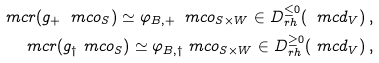<formula> <loc_0><loc_0><loc_500><loc_500>\ m c r ( g _ { + } \ m c o _ { S } ) \simeq \varphi _ { B , + } \ m c o _ { S \times W } \in D ^ { \leq 0 } _ { r h } ( \ m c d _ { V } ) \, , \\ \ m c r ( g _ { \dag } \ m c o _ { S } ) \simeq \varphi _ { B , \dag } \ m c o _ { S \times W } \in D ^ { \geq 0 } _ { r h } ( \ m c d _ { V } ) \, ,</formula> 